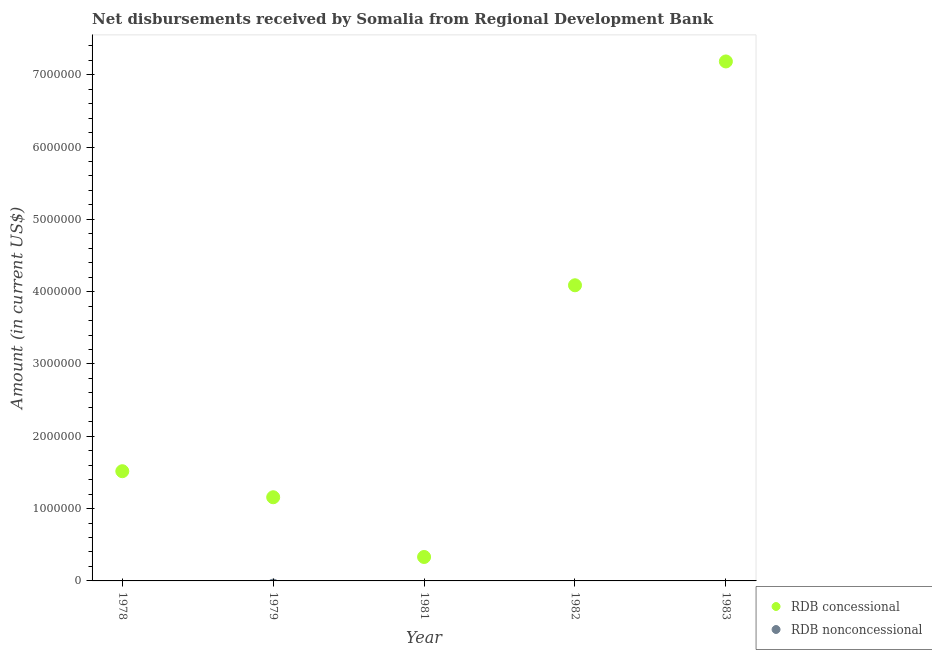How many different coloured dotlines are there?
Keep it short and to the point. 1. What is the net concessional disbursements from rdb in 1981?
Offer a terse response. 3.31e+05. Across all years, what is the maximum net concessional disbursements from rdb?
Your response must be concise. 7.18e+06. Across all years, what is the minimum net concessional disbursements from rdb?
Your answer should be compact. 3.31e+05. In which year was the net concessional disbursements from rdb maximum?
Your answer should be very brief. 1983. What is the total net concessional disbursements from rdb in the graph?
Make the answer very short. 1.43e+07. What is the difference between the net concessional disbursements from rdb in 1981 and that in 1983?
Provide a short and direct response. -6.85e+06. What is the difference between the net non concessional disbursements from rdb in 1982 and the net concessional disbursements from rdb in 1981?
Provide a short and direct response. -3.31e+05. What is the average net non concessional disbursements from rdb per year?
Offer a terse response. 0. In how many years, is the net concessional disbursements from rdb greater than 5000000 US$?
Make the answer very short. 1. What is the ratio of the net concessional disbursements from rdb in 1978 to that in 1982?
Keep it short and to the point. 0.37. Is the net concessional disbursements from rdb in 1979 less than that in 1983?
Give a very brief answer. Yes. What is the difference between the highest and the second highest net concessional disbursements from rdb?
Keep it short and to the point. 3.10e+06. What is the difference between the highest and the lowest net concessional disbursements from rdb?
Your answer should be very brief. 6.85e+06. Is the sum of the net concessional disbursements from rdb in 1978 and 1982 greater than the maximum net non concessional disbursements from rdb across all years?
Your answer should be compact. Yes. How many years are there in the graph?
Provide a short and direct response. 5. What is the difference between two consecutive major ticks on the Y-axis?
Give a very brief answer. 1.00e+06. Are the values on the major ticks of Y-axis written in scientific E-notation?
Your answer should be compact. No. Does the graph contain grids?
Your answer should be compact. No. Where does the legend appear in the graph?
Your answer should be compact. Bottom right. How many legend labels are there?
Provide a short and direct response. 2. How are the legend labels stacked?
Ensure brevity in your answer.  Vertical. What is the title of the graph?
Offer a terse response. Net disbursements received by Somalia from Regional Development Bank. What is the label or title of the X-axis?
Ensure brevity in your answer.  Year. What is the label or title of the Y-axis?
Provide a short and direct response. Amount (in current US$). What is the Amount (in current US$) in RDB concessional in 1978?
Give a very brief answer. 1.52e+06. What is the Amount (in current US$) in RDB concessional in 1979?
Provide a succinct answer. 1.16e+06. What is the Amount (in current US$) of RDB concessional in 1981?
Your answer should be very brief. 3.31e+05. What is the Amount (in current US$) of RDB nonconcessional in 1981?
Keep it short and to the point. 0. What is the Amount (in current US$) of RDB concessional in 1982?
Keep it short and to the point. 4.09e+06. What is the Amount (in current US$) of RDB concessional in 1983?
Provide a succinct answer. 7.18e+06. Across all years, what is the maximum Amount (in current US$) in RDB concessional?
Provide a succinct answer. 7.18e+06. Across all years, what is the minimum Amount (in current US$) of RDB concessional?
Give a very brief answer. 3.31e+05. What is the total Amount (in current US$) of RDB concessional in the graph?
Your response must be concise. 1.43e+07. What is the difference between the Amount (in current US$) of RDB concessional in 1978 and that in 1979?
Offer a terse response. 3.60e+05. What is the difference between the Amount (in current US$) in RDB concessional in 1978 and that in 1981?
Ensure brevity in your answer.  1.19e+06. What is the difference between the Amount (in current US$) of RDB concessional in 1978 and that in 1982?
Provide a short and direct response. -2.57e+06. What is the difference between the Amount (in current US$) of RDB concessional in 1978 and that in 1983?
Provide a short and direct response. -5.67e+06. What is the difference between the Amount (in current US$) of RDB concessional in 1979 and that in 1981?
Keep it short and to the point. 8.26e+05. What is the difference between the Amount (in current US$) in RDB concessional in 1979 and that in 1982?
Give a very brief answer. -2.93e+06. What is the difference between the Amount (in current US$) of RDB concessional in 1979 and that in 1983?
Offer a terse response. -6.03e+06. What is the difference between the Amount (in current US$) of RDB concessional in 1981 and that in 1982?
Keep it short and to the point. -3.76e+06. What is the difference between the Amount (in current US$) in RDB concessional in 1981 and that in 1983?
Keep it short and to the point. -6.85e+06. What is the difference between the Amount (in current US$) in RDB concessional in 1982 and that in 1983?
Provide a succinct answer. -3.10e+06. What is the average Amount (in current US$) of RDB concessional per year?
Give a very brief answer. 2.86e+06. What is the average Amount (in current US$) of RDB nonconcessional per year?
Your answer should be compact. 0. What is the ratio of the Amount (in current US$) in RDB concessional in 1978 to that in 1979?
Your response must be concise. 1.31. What is the ratio of the Amount (in current US$) of RDB concessional in 1978 to that in 1981?
Keep it short and to the point. 4.58. What is the ratio of the Amount (in current US$) of RDB concessional in 1978 to that in 1982?
Make the answer very short. 0.37. What is the ratio of the Amount (in current US$) in RDB concessional in 1978 to that in 1983?
Give a very brief answer. 0.21. What is the ratio of the Amount (in current US$) of RDB concessional in 1979 to that in 1981?
Provide a short and direct response. 3.5. What is the ratio of the Amount (in current US$) of RDB concessional in 1979 to that in 1982?
Keep it short and to the point. 0.28. What is the ratio of the Amount (in current US$) in RDB concessional in 1979 to that in 1983?
Keep it short and to the point. 0.16. What is the ratio of the Amount (in current US$) in RDB concessional in 1981 to that in 1982?
Keep it short and to the point. 0.08. What is the ratio of the Amount (in current US$) in RDB concessional in 1981 to that in 1983?
Your response must be concise. 0.05. What is the ratio of the Amount (in current US$) of RDB concessional in 1982 to that in 1983?
Your response must be concise. 0.57. What is the difference between the highest and the second highest Amount (in current US$) in RDB concessional?
Make the answer very short. 3.10e+06. What is the difference between the highest and the lowest Amount (in current US$) of RDB concessional?
Your response must be concise. 6.85e+06. 